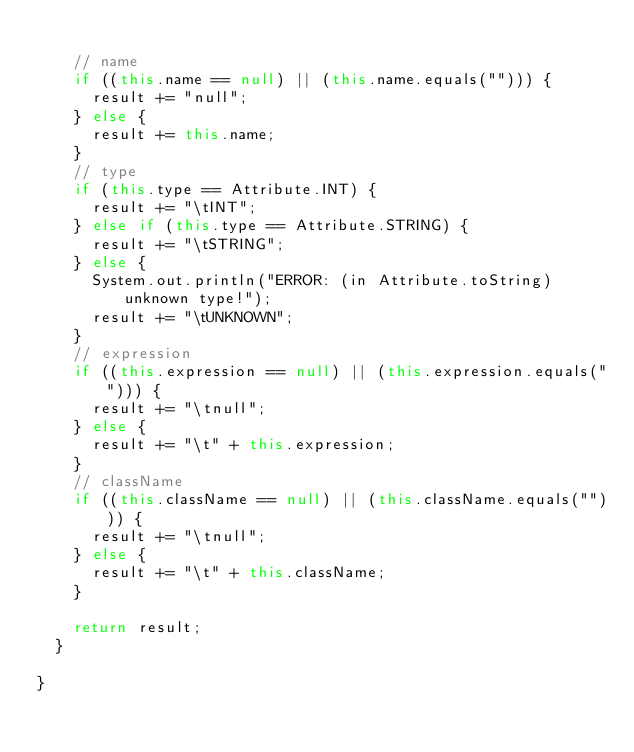Convert code to text. <code><loc_0><loc_0><loc_500><loc_500><_Java_>
		// name
		if ((this.name == null) || (this.name.equals(""))) {
			result += "null";
		} else {
			result += this.name;
		}
		// type
		if (this.type == Attribute.INT) {
			result += "\tINT";
		} else if (this.type == Attribute.STRING) {
			result += "\tSTRING";
		} else {
			System.out.println("ERROR: (in Attribute.toString) unknown type!");
			result += "\tUNKNOWN";
		}
		// expression
		if ((this.expression == null) || (this.expression.equals(""))) {
			result += "\tnull";
		} else {
			result += "\t" + this.expression;
		}
		// className
		if ((this.className == null) || (this.className.equals(""))) {
			result += "\tnull";
		} else {
			result += "\t" + this.className;
		}

		return result;
	}

}

</code> 